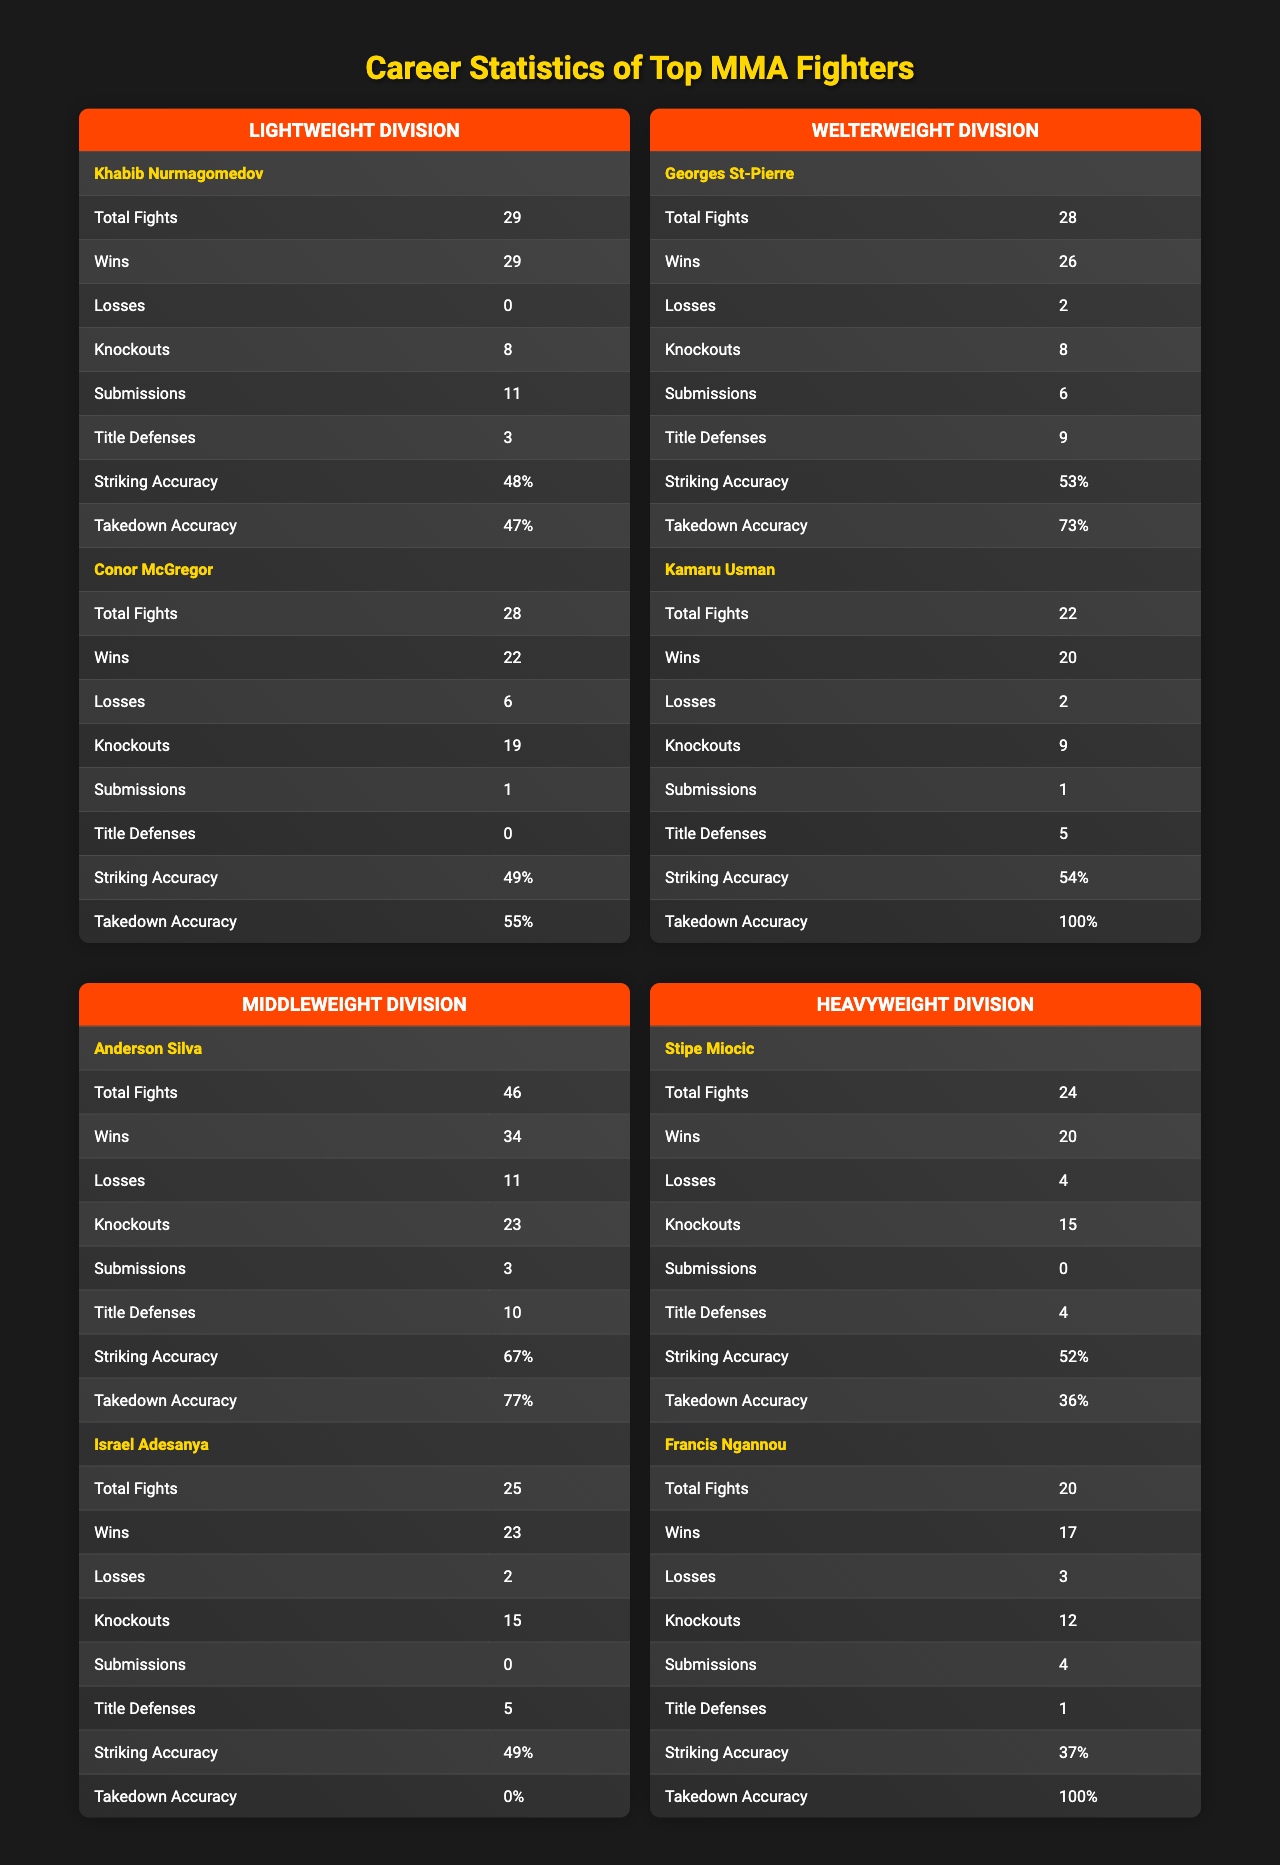What is the total number of fights for Khabib Nurmagomedov? The table lists Khabib Nurmagomedov under the Lightweight Division, and the "Total Fights" statistic shows 29.
Answer: 29 Who has a higher striking accuracy, Conor McGregor or Georges St-Pierre? Comparing the "Striking Accuracy" values in the table, Conor McGregor has 49% and Georges St-Pierre has 53%. Since 53% is greater than 49%, Georges St-Pierre has a higher striking accuracy.
Answer: Georges St-Pierre What is the combined number of wins for fighters in the Heavyweight Division? The table lists Stipe Miocic with 20 wins and Francis Ngannou with 17 wins. Summing these gives 20 + 17 = 37.
Answer: 37 Did Kamaru Usman have more knockouts than Georges St-Pierre? Kamaru Usman has 9 knockouts while Georges St-Pierre has 8. Since 9 is greater than 8, the statement is true.
Answer: Yes What is the average number of title defenses in the Middleweight Division? From the table, Anderson Silva has 10 title defenses and Israel Adesanya has 5. To find the average, sum 10 + 5 = 15, and divide by 2 (the number of fighters): 15 / 2 = 7.5.
Answer: 7.5 How many more losses does Anderson Silva have compared to Khabib Nurmagomedov? Anderson Silva has 11 losses and Khabib Nurmagomedov has 0. Calculating the difference gives 11 - 0 = 11.
Answer: 11 Is it true that all fighters under the Lightweight Division have finished their fights with either a KO or submission? Khabib Nurmagomedov has 8 knockouts and 11 submissions, while Conor McGregor has 19 knockouts and 1 submission, indicating all their wins are through finishes. Thus, the statement is true.
Answer: Yes Which MMA fighter achieved the most title defenses, and how many did they have? The table indicates Georges St-Pierre with 9 title defenses and Anderson Silva with 10. Therefore, the fighter with the most title defenses is Anderson Silva, with 10.
Answer: Anderson Silva, 10 How does Kamaru Usman's takedown accuracy compare to the average takedown accuracy of fighters in the Welterweight Division? Kamaru Usman's takedown accuracy is 100%. To find the average, we take Georges St-Pierre's 73% and Kamaru Usman's 100%, sum them (73 + 100 = 173), and divide by 2, giving 86.5. Since 100% is significantly greater than 86.5%, Kamaru Usman's takedown accuracy is higher.
Answer: Higher What is the total number of submissions achieved by fighters in the Lightweight Division? Khabib Nurmagomedov has 11 submissions and Conor McGregor has 1. By summing these values: 11 + 1 = 12.
Answer: 12 